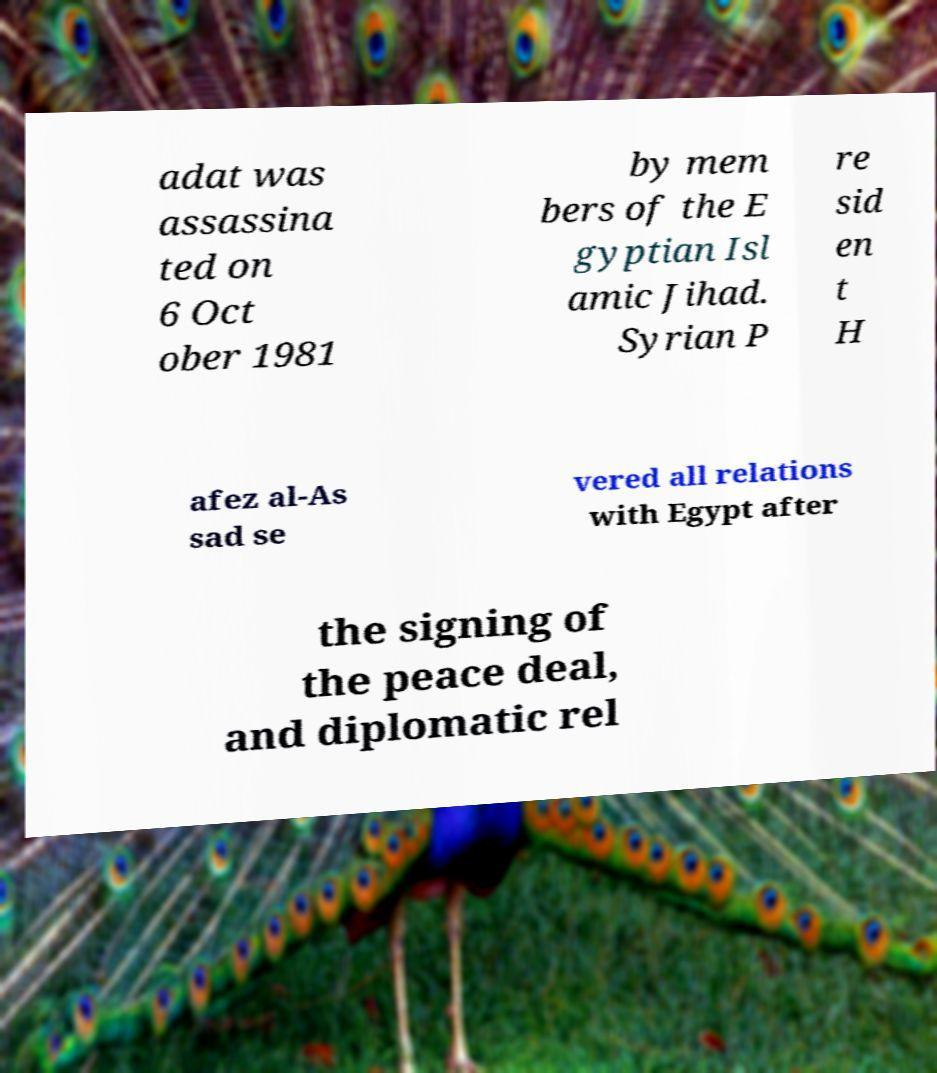Could you assist in decoding the text presented in this image and type it out clearly? adat was assassina ted on 6 Oct ober 1981 by mem bers of the E gyptian Isl amic Jihad. Syrian P re sid en t H afez al-As sad se vered all relations with Egypt after the signing of the peace deal, and diplomatic rel 